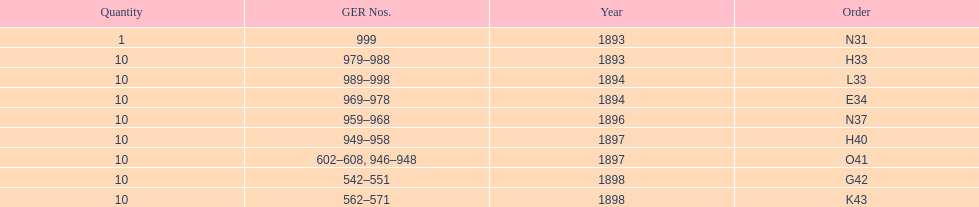Write the full table. {'header': ['Quantity', 'GER Nos.', 'Year', 'Order'], 'rows': [['1', '999', '1893', 'N31'], ['10', '979–988', '1893', 'H33'], ['10', '989–998', '1894', 'L33'], ['10', '969–978', '1894', 'E34'], ['10', '959–968', '1896', 'N37'], ['10', '949–958', '1897', 'H40'], ['10', '602–608, 946–948', '1897', 'O41'], ['10', '542–551', '1898', 'G42'], ['10', '562–571', '1898', 'K43']]} Were there more n31 or e34 ordered? E34. 